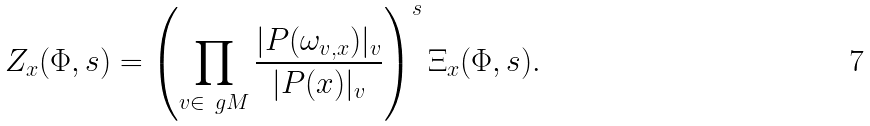Convert formula to latex. <formula><loc_0><loc_0><loc_500><loc_500>Z _ { x } ( \Phi , s ) = \left ( \prod _ { v \in \ g M } \frac { | P ( \omega _ { v , x } ) | _ { v } } { | P ( x ) | _ { v } } \right ) ^ { s } \Xi _ { x } ( \Phi , s ) .</formula> 